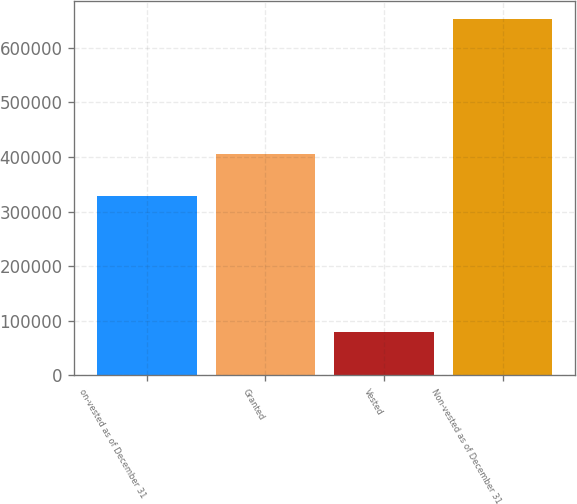<chart> <loc_0><loc_0><loc_500><loc_500><bar_chart><fcel>on-vested as of December 31<fcel>Granted<fcel>Vested<fcel>Non-vested as of December 31<nl><fcel>328385<fcel>404889<fcel>80434<fcel>652840<nl></chart> 